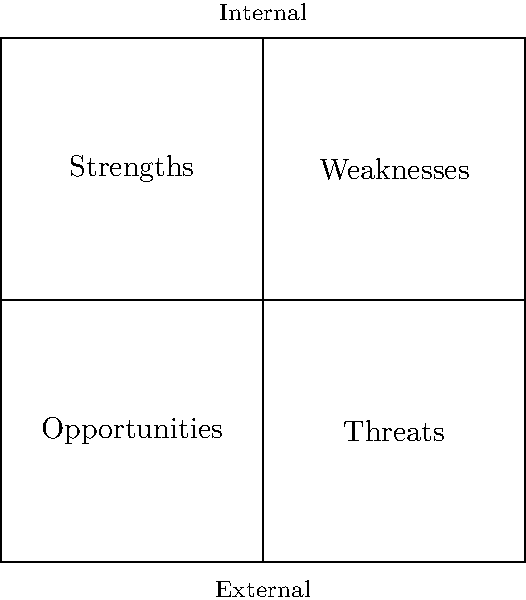In the SWOT analysis quadrant diagram shown above, which quadrant represents factors that are both internal to the organization and potentially harmful to achieving its objectives? To answer this question, we need to analyze the SWOT (Strengths, Weaknesses, Opportunities, Threats) diagram and understand the characteristics of each quadrant:

1. The diagram is divided into four quadrants, each representing a different aspect of the SWOT analysis.

2. The vertical axis divides the diagram into internal (top half) and external (bottom half) factors.

3. The horizontal axis divides the diagram into positive (left side) and negative (right side) factors.

4. Each quadrant is labeled with one of the SWOT components:
   - Top-left: Strengths (internal and positive)
   - Top-right: Weaknesses (internal and negative)
   - Bottom-left: Opportunities (external and positive)
   - Bottom-right: Threats (external and negative)

5. The question asks for factors that are both internal to the organization and potentially harmful to achieving its objectives.

6. Internal factors are represented in the top half of the diagram.

7. Potentially harmful (negative) factors are represented on the right side of the diagram.

8. The quadrant that satisfies both conditions (internal and negative) is the top-right quadrant, which is labeled "Weaknesses."

Therefore, the quadrant that represents factors that are both internal to the organization and potentially harmful to achieving its objectives is the Weaknesses quadrant.
Answer: Weaknesses 